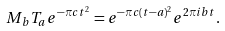Convert formula to latex. <formula><loc_0><loc_0><loc_500><loc_500>M _ { b } T _ { a } e ^ { - \pi c t ^ { 2 } } = e ^ { - \pi c ( t - a ) ^ { 2 } } e ^ { 2 \pi i b t } .</formula> 